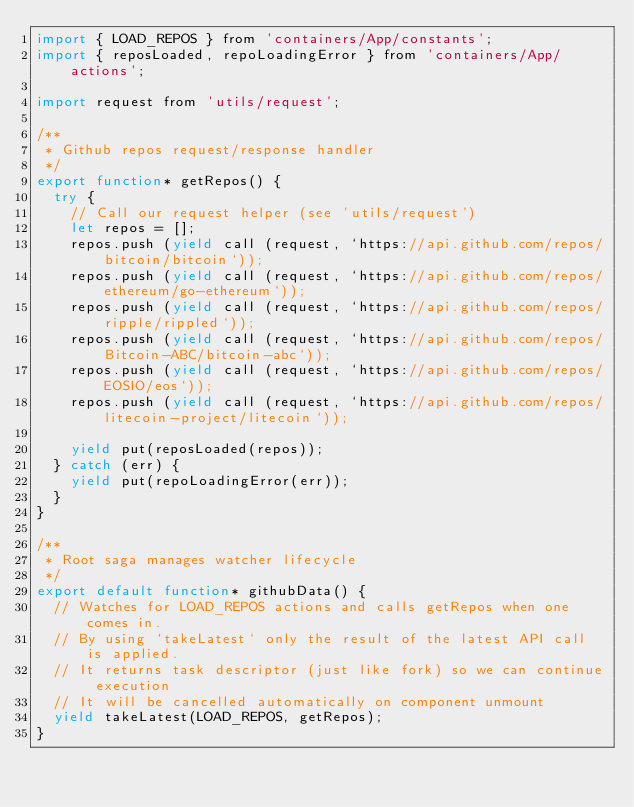Convert code to text. <code><loc_0><loc_0><loc_500><loc_500><_JavaScript_>import { LOAD_REPOS } from 'containers/App/constants';
import { reposLoaded, repoLoadingError } from 'containers/App/actions';

import request from 'utils/request';

/**
 * Github repos request/response handler
 */
export function* getRepos() {
  try {
    // Call our request helper (see 'utils/request')
    let repos = []; 
    repos.push (yield call (request, `https://api.github.com/repos/bitcoin/bitcoin`));
    repos.push (yield call (request, `https://api.github.com/repos/ethereum/go-ethereum`));
    repos.push (yield call (request, `https://api.github.com/repos/ripple/rippled`));
    repos.push (yield call (request, `https://api.github.com/repos/Bitcoin-ABC/bitcoin-abc`));
    repos.push (yield call (request, `https://api.github.com/repos/EOSIO/eos`));
    repos.push (yield call (request, `https://api.github.com/repos/litecoin-project/litecoin`));

    yield put(reposLoaded(repos));
  } catch (err) {
    yield put(repoLoadingError(err));
  }
}

/**
 * Root saga manages watcher lifecycle
 */
export default function* githubData() {
  // Watches for LOAD_REPOS actions and calls getRepos when one comes in.
  // By using `takeLatest` only the result of the latest API call is applied.
  // It returns task descriptor (just like fork) so we can continue execution
  // It will be cancelled automatically on component unmount
  yield takeLatest(LOAD_REPOS, getRepos);
}
</code> 